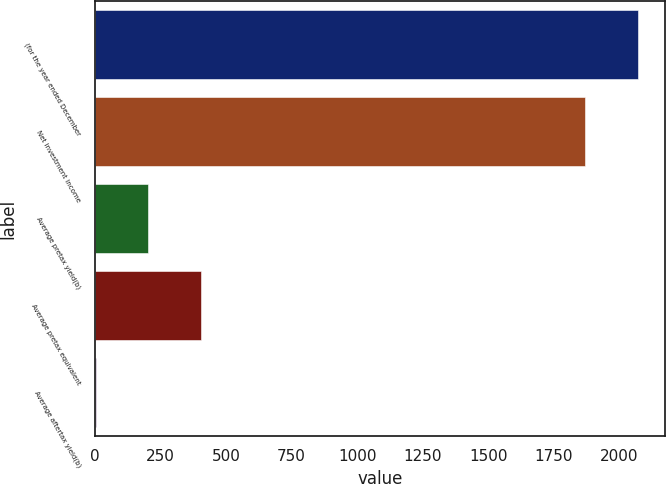Convert chart. <chart><loc_0><loc_0><loc_500><loc_500><bar_chart><fcel>(for the year ended December<fcel>Net investment income<fcel>Average pretax yield(b)<fcel>Average pretax equivalent<fcel>Average aftertax yield(b)<nl><fcel>2068.9<fcel>1869<fcel>203.9<fcel>403.8<fcel>4<nl></chart> 